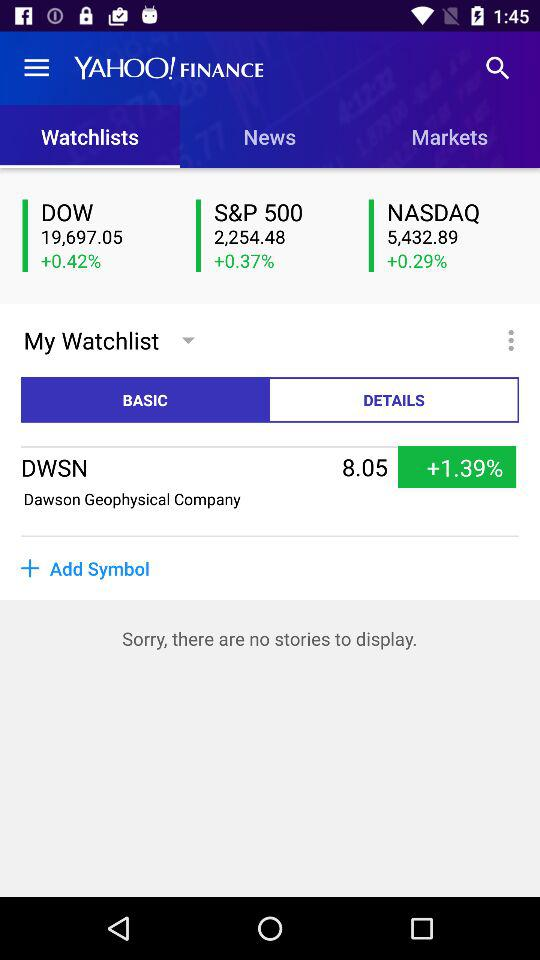What is the current price of DWSN?
Answer the question using a single word or phrase. 8.05 